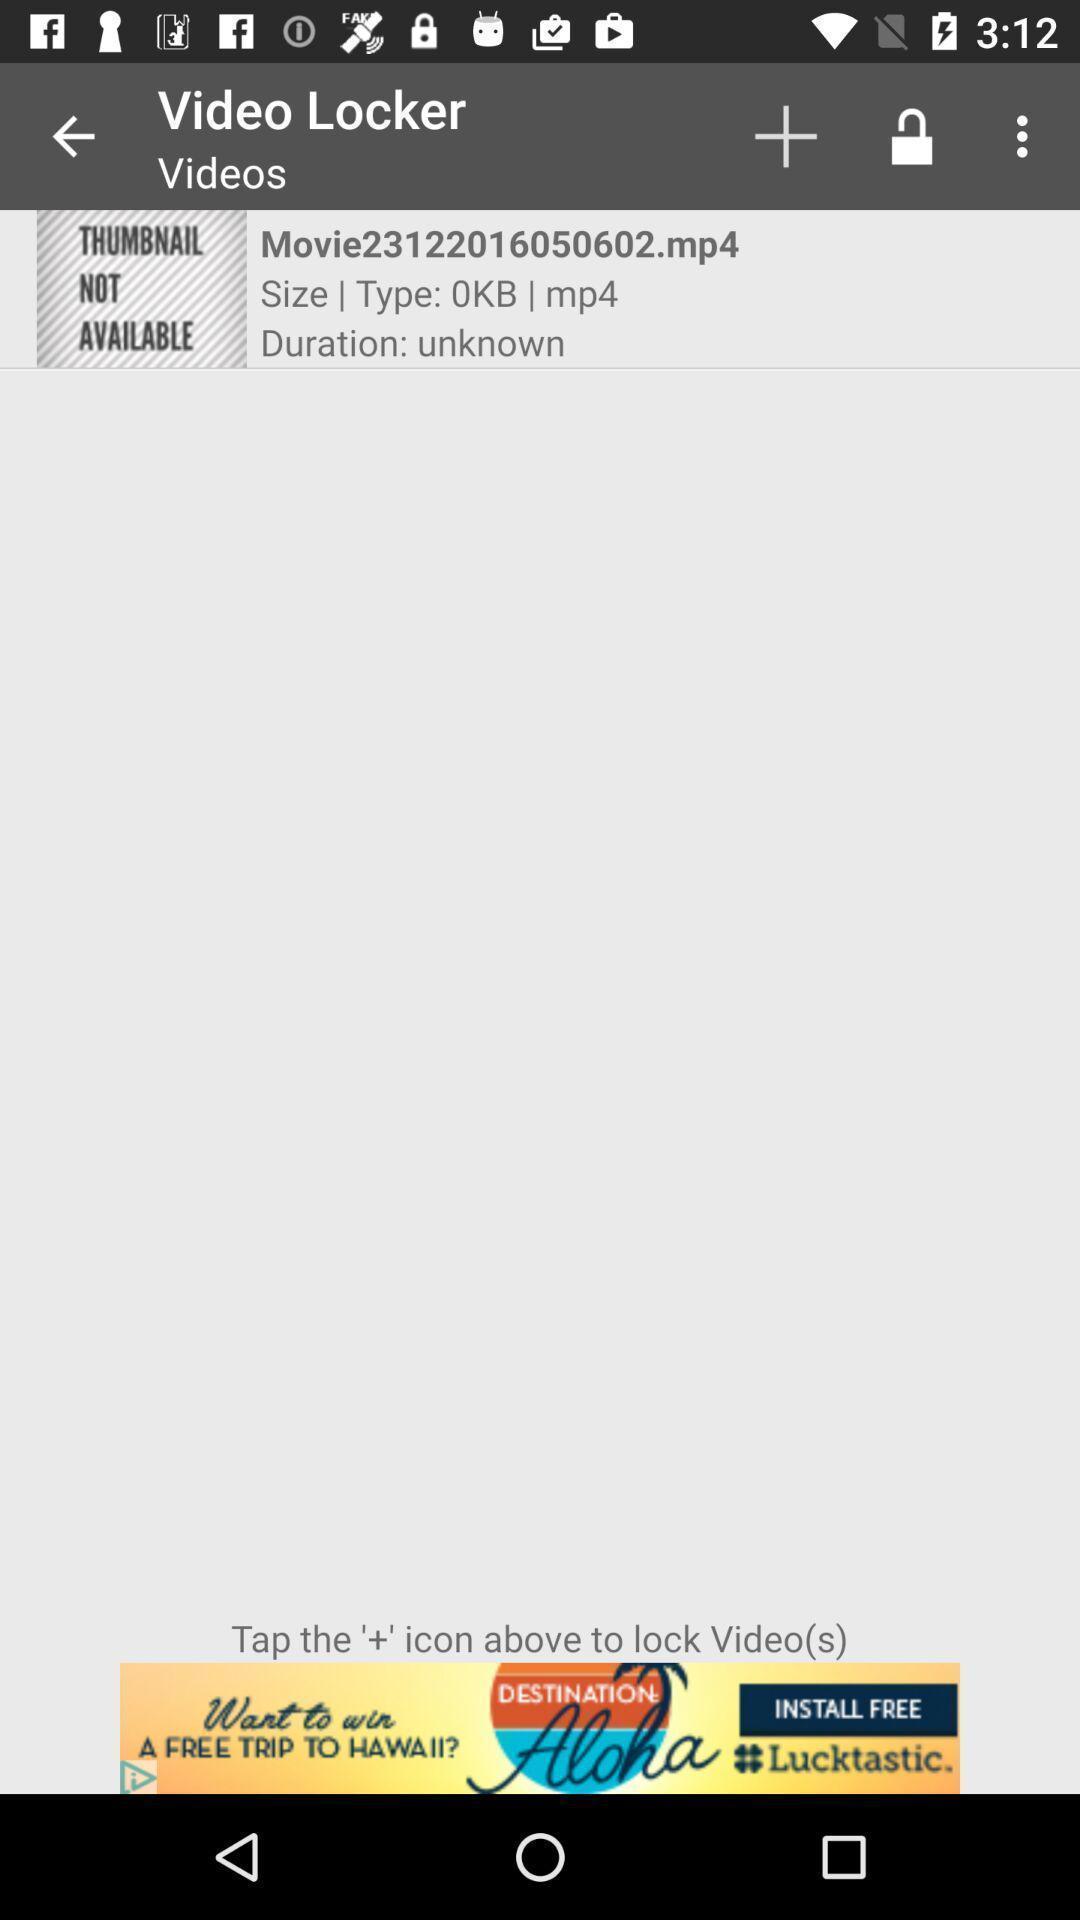Describe the visual elements of this screenshot. Screen shows videos in hiding videos application. 